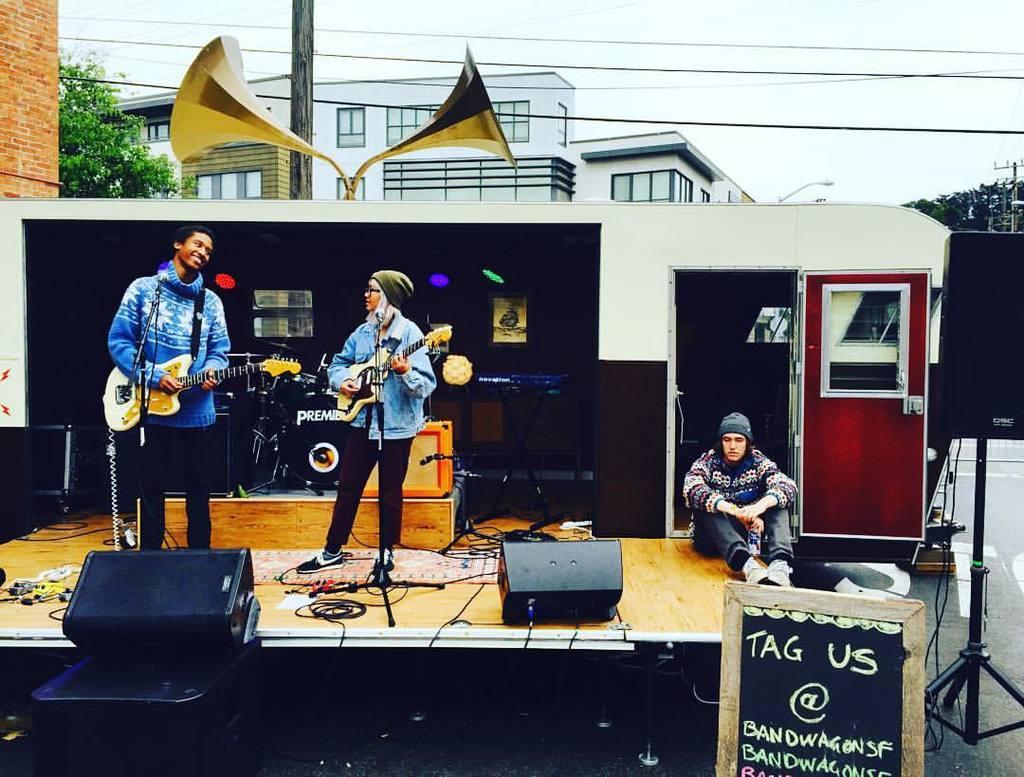Describe this image in one or two sentences. In this picture, we see the man and the women are standing. Both of them are holding the guitars in their hands and they are playing the guitars. In front of them, we see the microphones and speaker boxes. The woman on the right side is sitting on the stage. Behind her, we see a wall in white and red color. In front of her, we see a board in black color with some text written on it. Beside that, we see the stand and speaker box. In the background, we see the megaphones, trees, electric poles, wires and buildings. At the top, we see the sky. 